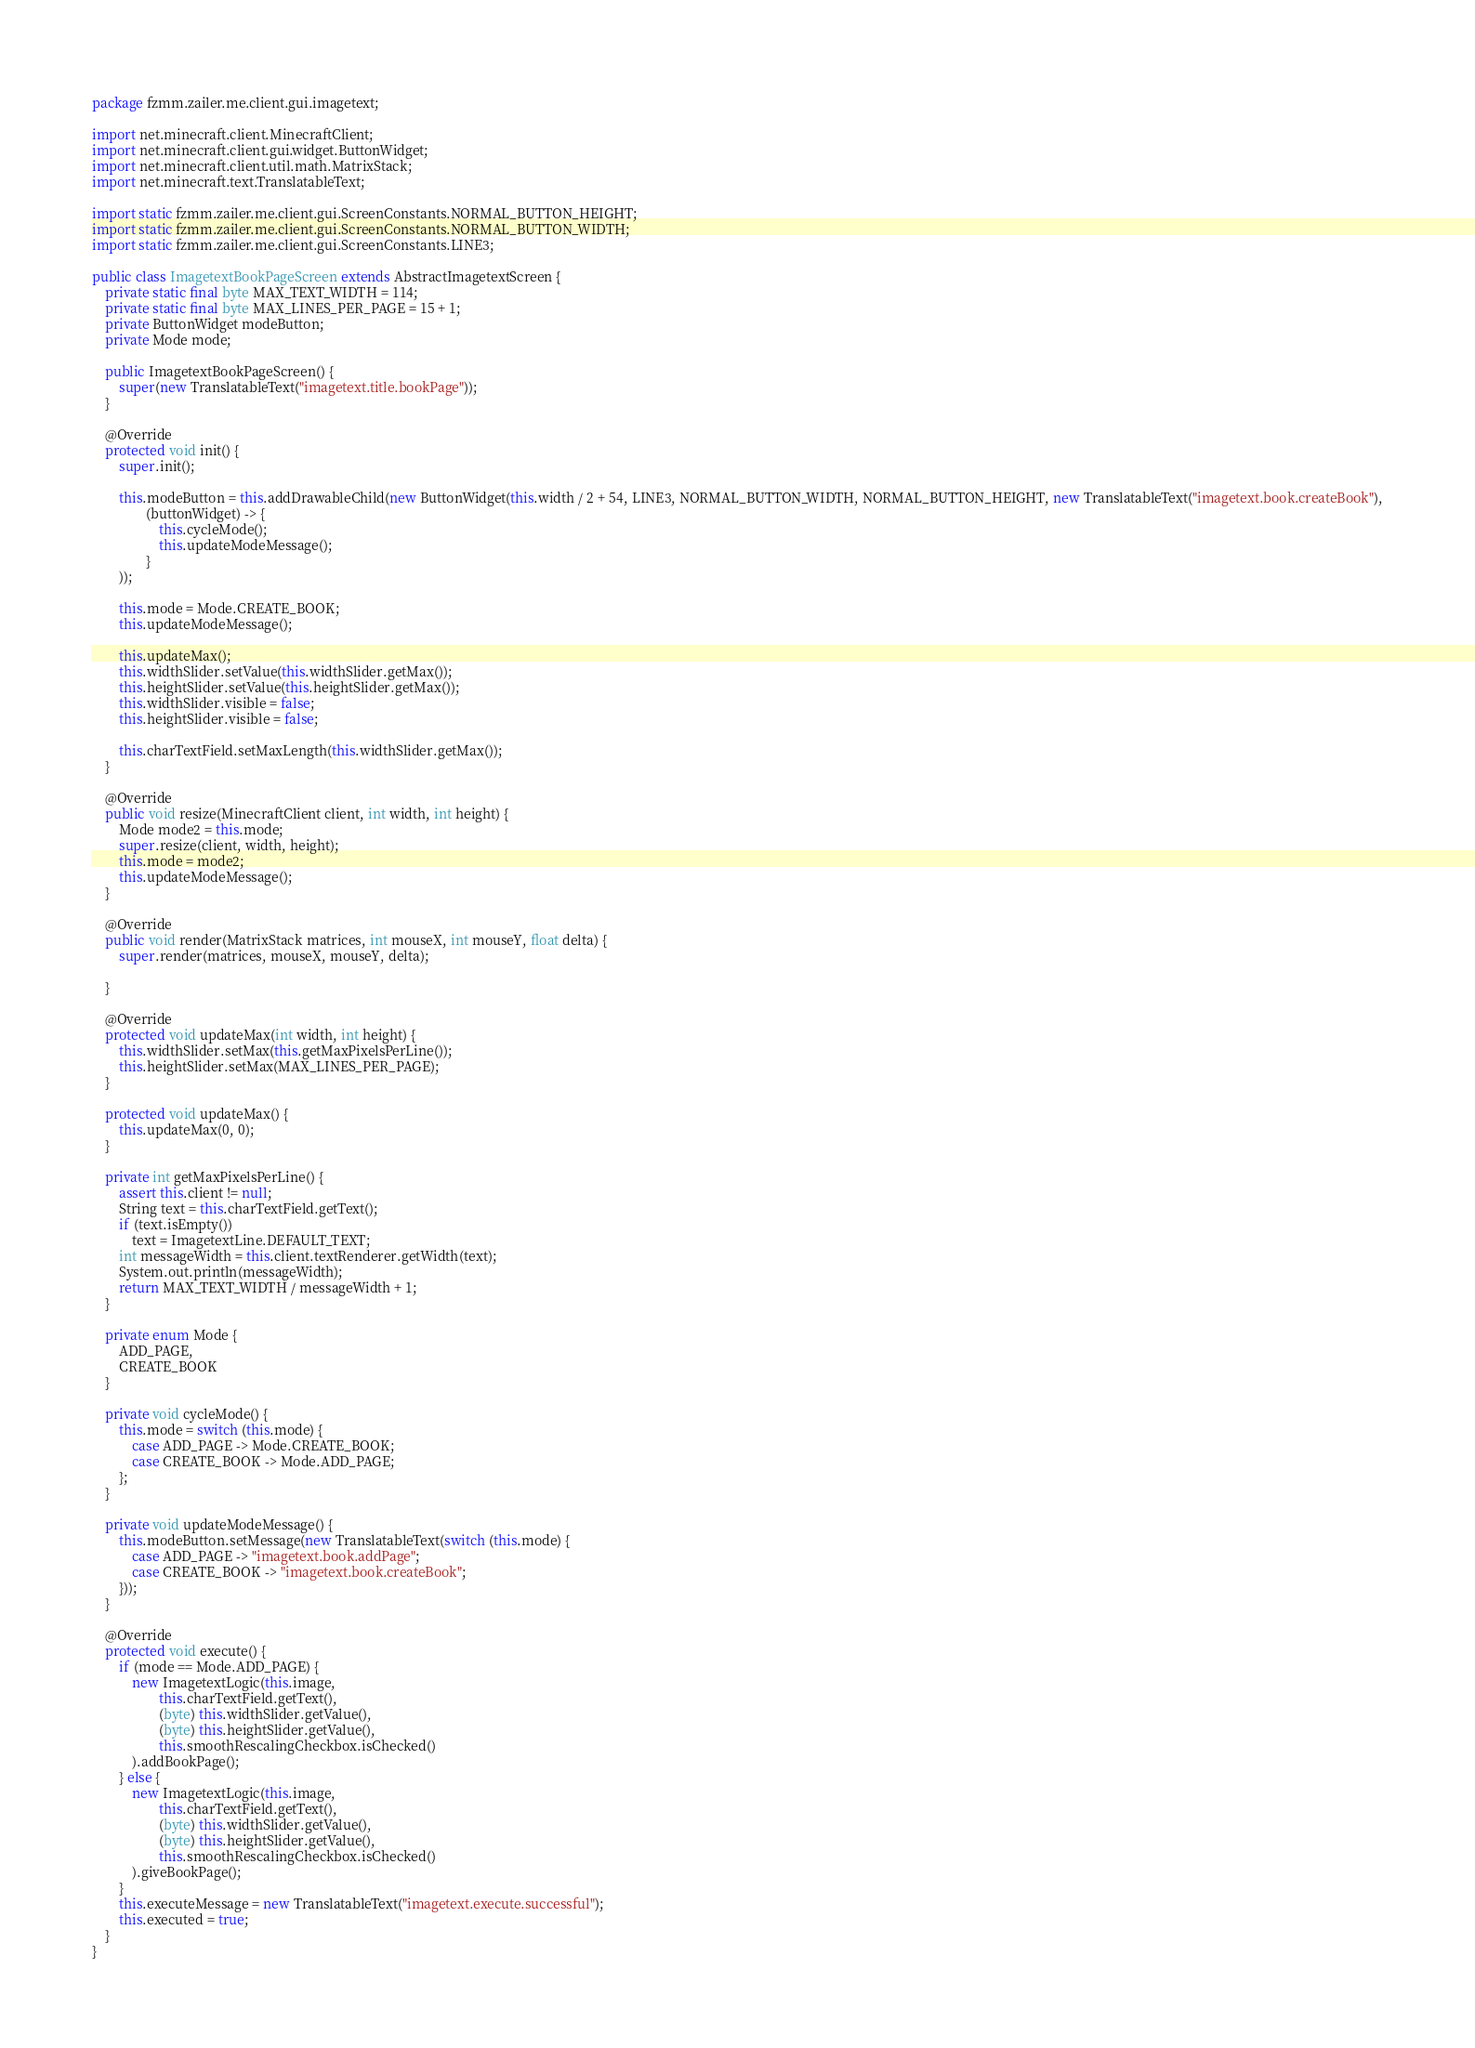<code> <loc_0><loc_0><loc_500><loc_500><_Java_>package fzmm.zailer.me.client.gui.imagetext;

import net.minecraft.client.MinecraftClient;
import net.minecraft.client.gui.widget.ButtonWidget;
import net.minecraft.client.util.math.MatrixStack;
import net.minecraft.text.TranslatableText;

import static fzmm.zailer.me.client.gui.ScreenConstants.NORMAL_BUTTON_HEIGHT;
import static fzmm.zailer.me.client.gui.ScreenConstants.NORMAL_BUTTON_WIDTH;
import static fzmm.zailer.me.client.gui.ScreenConstants.LINE3;

public class ImagetextBookPageScreen extends AbstractImagetextScreen {
    private static final byte MAX_TEXT_WIDTH = 114;
    private static final byte MAX_LINES_PER_PAGE = 15 + 1;
    private ButtonWidget modeButton;
    private Mode mode;

    public ImagetextBookPageScreen() {
        super(new TranslatableText("imagetext.title.bookPage"));
    }

    @Override
    protected void init() {
        super.init();

        this.modeButton = this.addDrawableChild(new ButtonWidget(this.width / 2 + 54, LINE3, NORMAL_BUTTON_WIDTH, NORMAL_BUTTON_HEIGHT, new TranslatableText("imagetext.book.createBook"),
                (buttonWidget) -> {
                    this.cycleMode();
                    this.updateModeMessage();
                }
        ));

        this.mode = Mode.CREATE_BOOK;
        this.updateModeMessage();

        this.updateMax();
        this.widthSlider.setValue(this.widthSlider.getMax());
        this.heightSlider.setValue(this.heightSlider.getMax());
        this.widthSlider.visible = false;
        this.heightSlider.visible = false;

        this.charTextField.setMaxLength(this.widthSlider.getMax());
    }

    @Override
    public void resize(MinecraftClient client, int width, int height) {
        Mode mode2 = this.mode;
        super.resize(client, width, height);
        this.mode = mode2;
        this.updateModeMessage();
    }

    @Override
    public void render(MatrixStack matrices, int mouseX, int mouseY, float delta) {
        super.render(matrices, mouseX, mouseY, delta);

    }

    @Override
    protected void updateMax(int width, int height) {
        this.widthSlider.setMax(this.getMaxPixelsPerLine());
        this.heightSlider.setMax(MAX_LINES_PER_PAGE);
    }

    protected void updateMax() {
        this.updateMax(0, 0);
    }

    private int getMaxPixelsPerLine() {
        assert this.client != null;
        String text = this.charTextField.getText();
        if (text.isEmpty())
            text = ImagetextLine.DEFAULT_TEXT;
        int messageWidth = this.client.textRenderer.getWidth(text);
        System.out.println(messageWidth);
        return MAX_TEXT_WIDTH / messageWidth + 1;
    }

    private enum Mode {
        ADD_PAGE,
        CREATE_BOOK
    }

    private void cycleMode() {
        this.mode = switch (this.mode) {
            case ADD_PAGE -> Mode.CREATE_BOOK;
            case CREATE_BOOK -> Mode.ADD_PAGE;
        };
    }

    private void updateModeMessage() {
        this.modeButton.setMessage(new TranslatableText(switch (this.mode) {
            case ADD_PAGE -> "imagetext.book.addPage";
            case CREATE_BOOK -> "imagetext.book.createBook";
        }));
    }

    @Override
    protected void execute() {
        if (mode == Mode.ADD_PAGE) {
            new ImagetextLogic(this.image,
                    this.charTextField.getText(),
                    (byte) this.widthSlider.getValue(),
                    (byte) this.heightSlider.getValue(),
                    this.smoothRescalingCheckbox.isChecked()
            ).addBookPage();
        } else {
            new ImagetextLogic(this.image,
                    this.charTextField.getText(),
                    (byte) this.widthSlider.getValue(),
                    (byte) this.heightSlider.getValue(),
                    this.smoothRescalingCheckbox.isChecked()
            ).giveBookPage();
        }
        this.executeMessage = new TranslatableText("imagetext.execute.successful");
        this.executed = true;
    }
}
</code> 